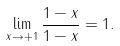<formula> <loc_0><loc_0><loc_500><loc_500>\lim _ { x \to + 1 } \frac { 1 - x } { 1 - x } = 1 .</formula> 